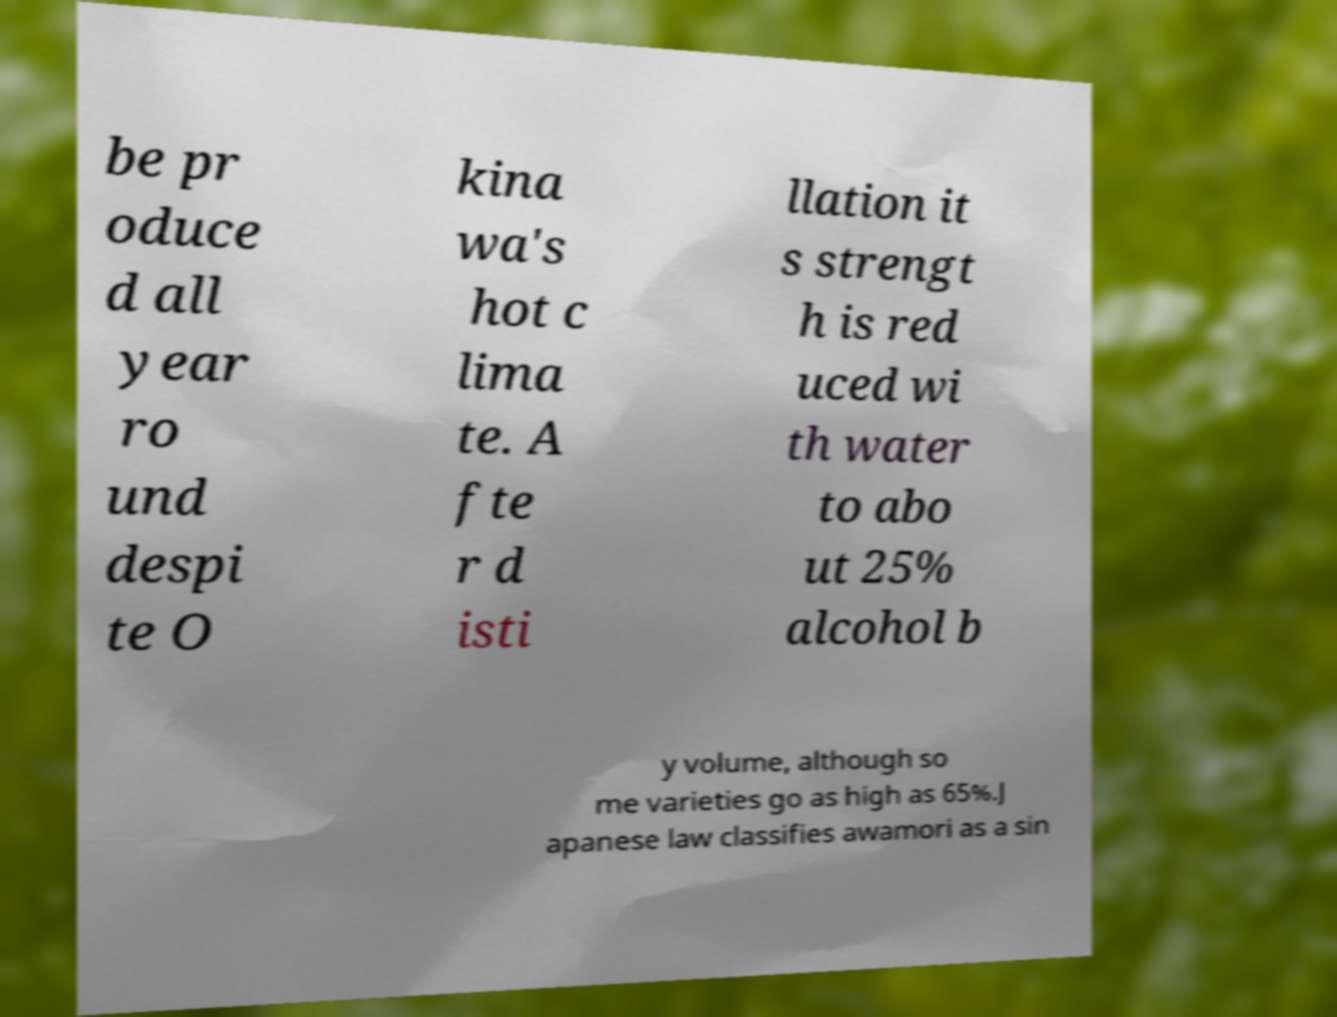Could you extract and type out the text from this image? be pr oduce d all year ro und despi te O kina wa's hot c lima te. A fte r d isti llation it s strengt h is red uced wi th water to abo ut 25% alcohol b y volume, although so me varieties go as high as 65%.J apanese law classifies awamori as a sin 